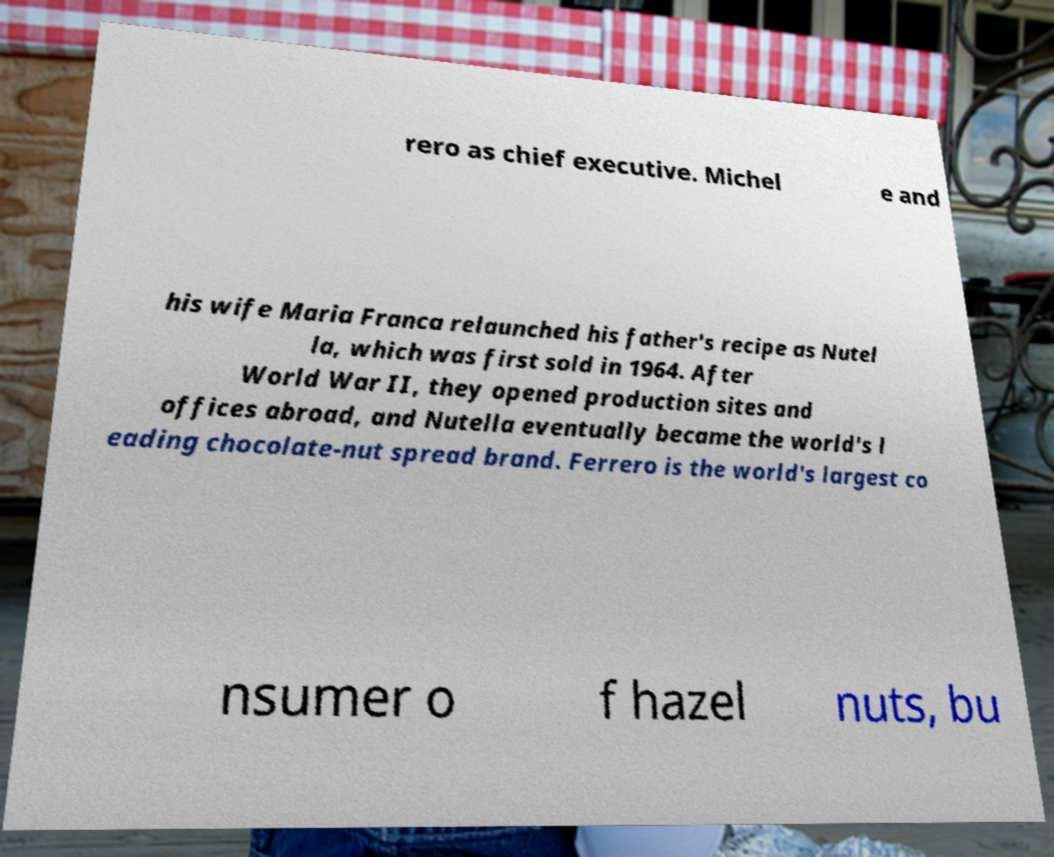What messages or text are displayed in this image? I need them in a readable, typed format. rero as chief executive. Michel e and his wife Maria Franca relaunched his father's recipe as Nutel la, which was first sold in 1964. After World War II, they opened production sites and offices abroad, and Nutella eventually became the world's l eading chocolate-nut spread brand. Ferrero is the world's largest co nsumer o f hazel nuts, bu 